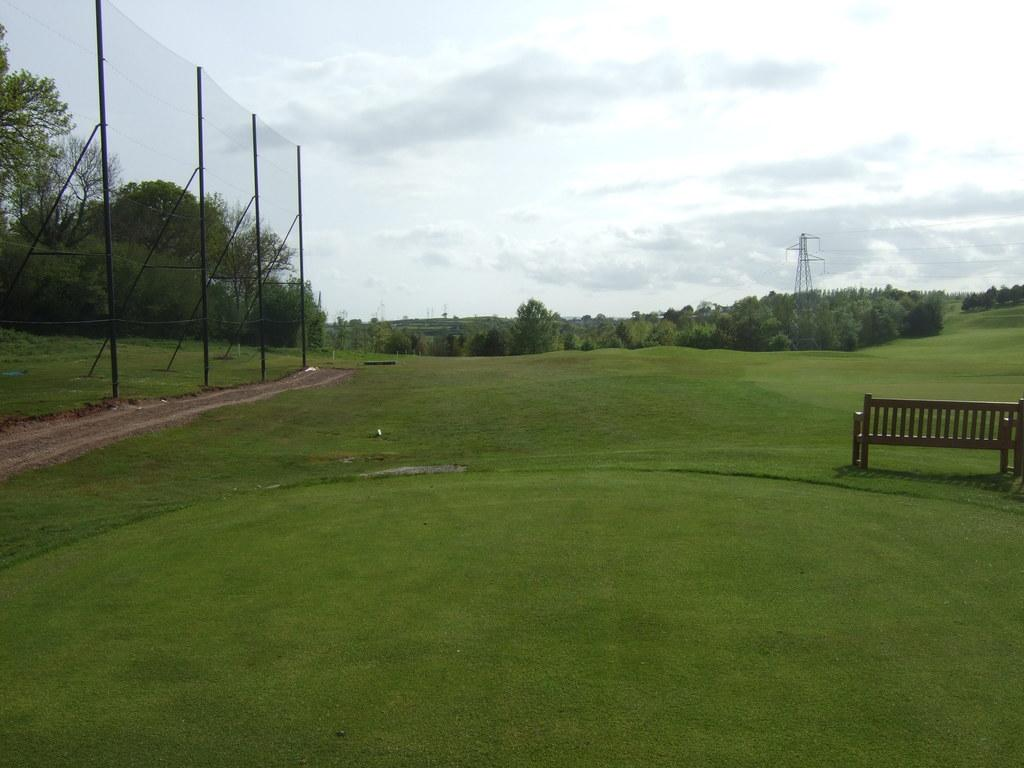What type of seating is visible in the image? There is a bench on the grass in the image. What other structures can be seen in the image? There is a fence and a cell tower in the image. What type of vegetation is present in the image? There are trees in the image. What can be seen in the background of the image? The sky is visible in the background of the image. What type of holiday is being celebrated in the image? There is no indication of a holiday being celebrated in the image. What color is the stocking hanging on the fence in the image? There is no stocking present in the image; it only features a bench, a fence, a cell tower, trees, and the sky. 